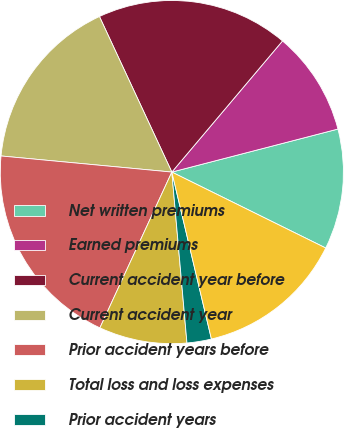Convert chart to OTSL. <chart><loc_0><loc_0><loc_500><loc_500><pie_chart><fcel>Net written premiums<fcel>Earned premiums<fcel>Current accident year before<fcel>Current accident year<fcel>Prior accident years before<fcel>Total loss and loss expenses<fcel>Prior accident years<fcel>Total loss and loss expense<nl><fcel>11.33%<fcel>9.81%<fcel>18.09%<fcel>16.57%<fcel>19.61%<fcel>8.29%<fcel>2.3%<fcel>14.0%<nl></chart> 